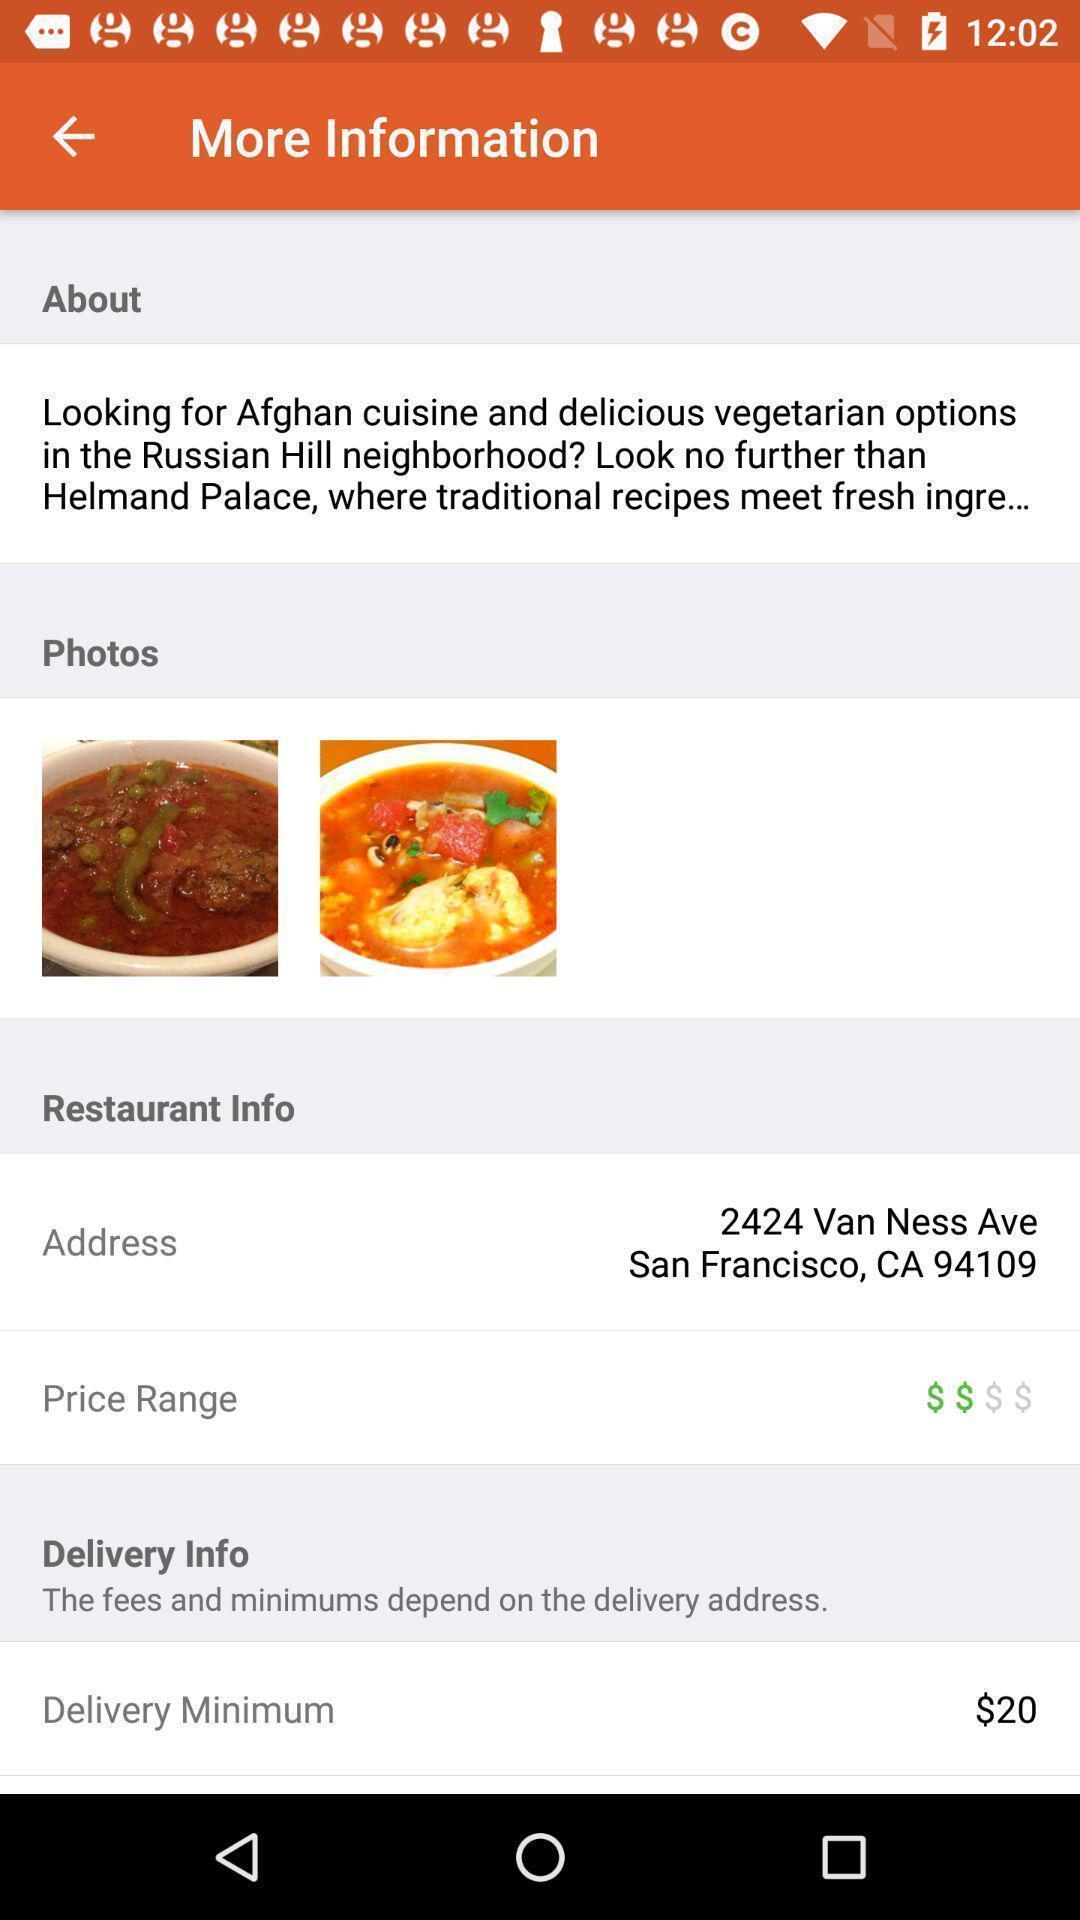Tell me about the visual elements in this screen capture. Screen page of a food application. 